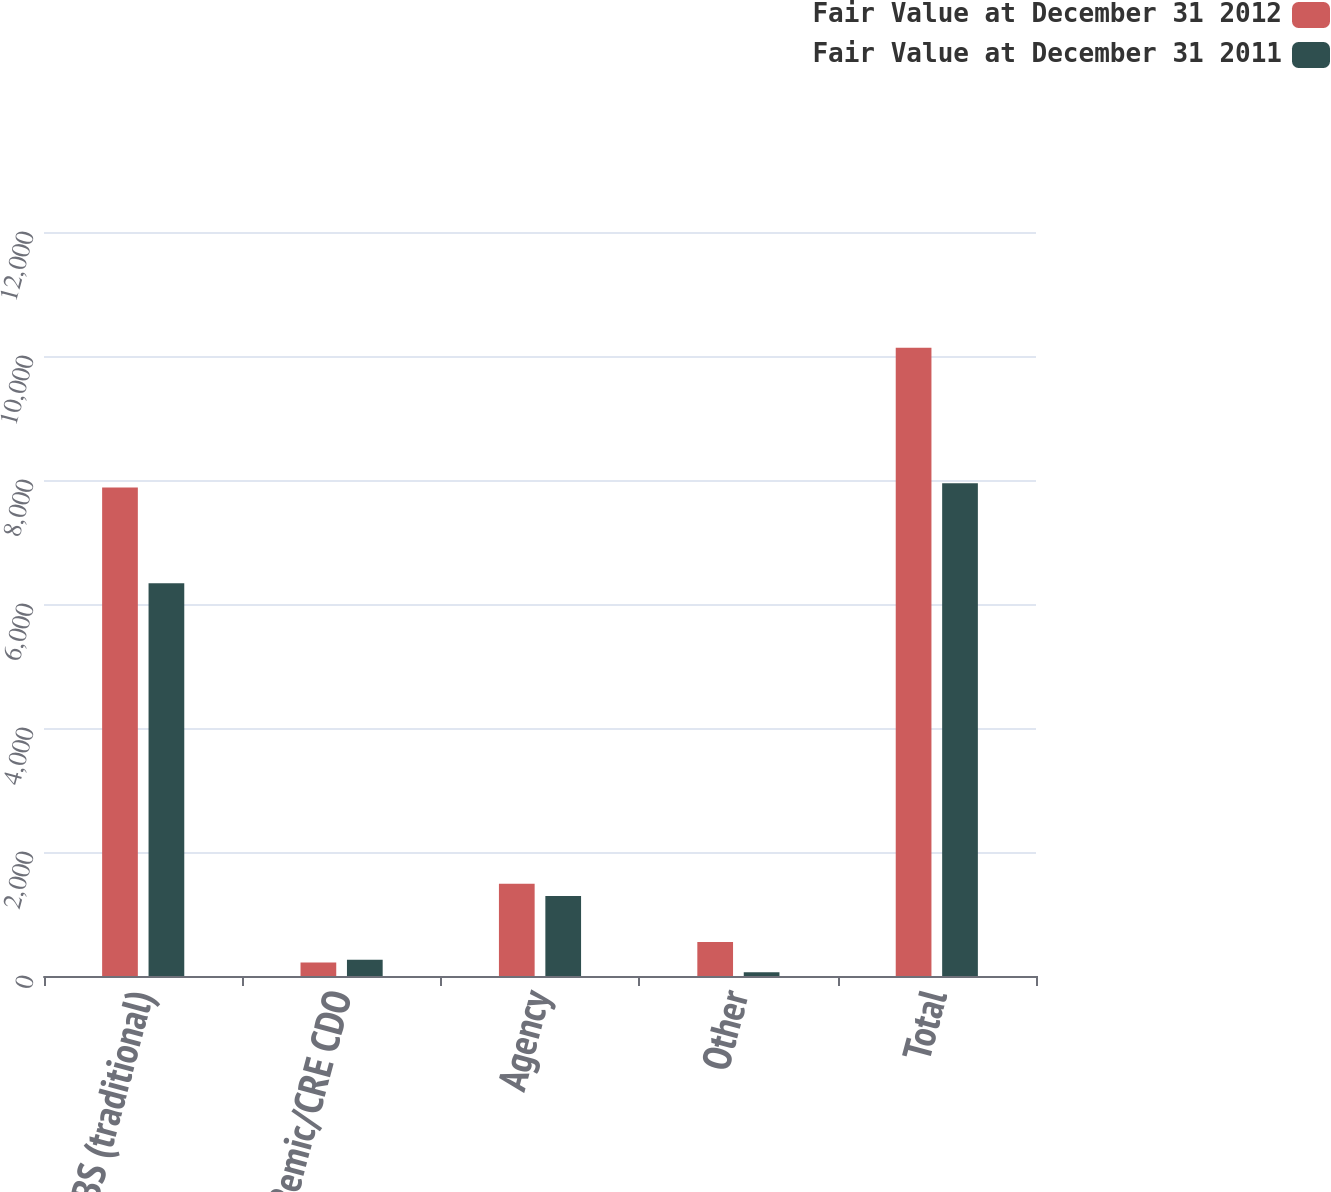Convert chart to OTSL. <chart><loc_0><loc_0><loc_500><loc_500><stacked_bar_chart><ecel><fcel>CMBS (traditional)<fcel>ReRemic/CRE CDO<fcel>Agency<fcel>Other<fcel>Total<nl><fcel>Fair Value at December 31 2012<fcel>7880<fcel>219<fcel>1486<fcel>549<fcel>10134<nl><fcel>Fair Value at December 31 2011<fcel>6333<fcel>261<fcel>1290<fcel>62<fcel>7946<nl></chart> 